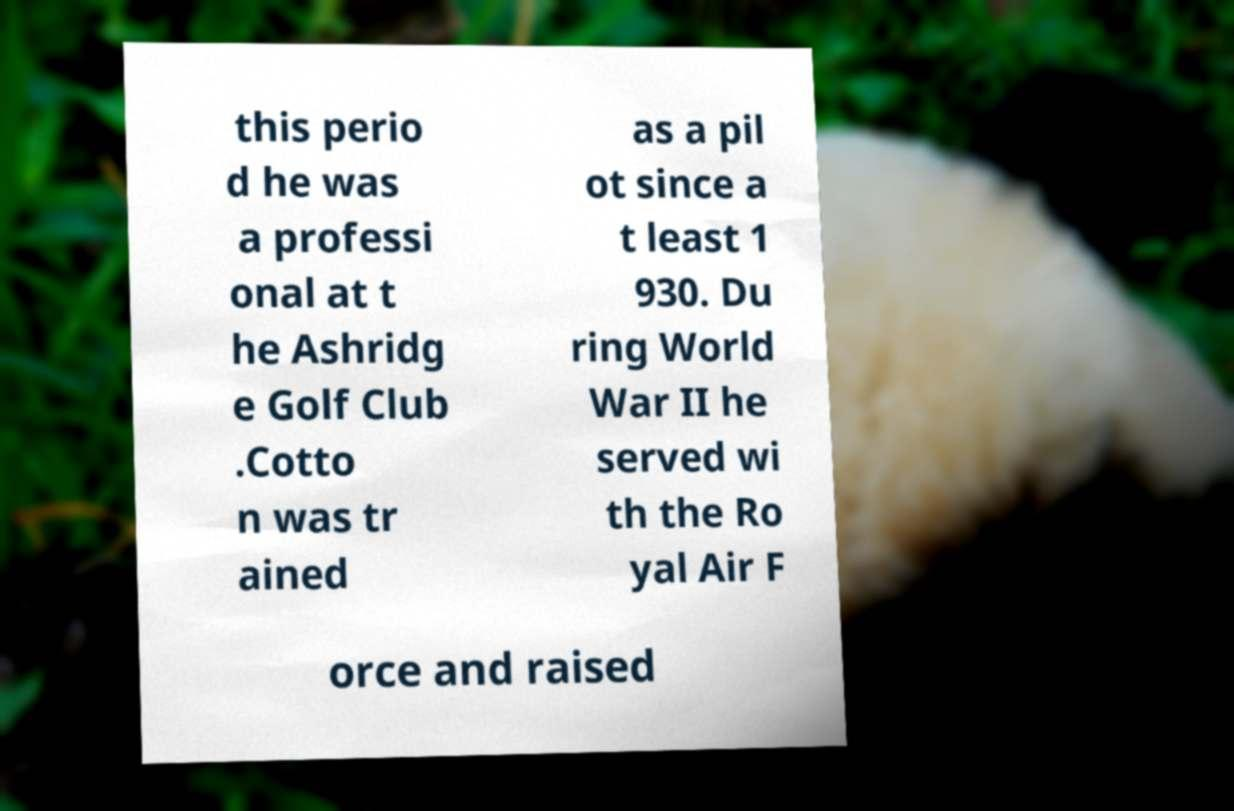There's text embedded in this image that I need extracted. Can you transcribe it verbatim? this perio d he was a professi onal at t he Ashridg e Golf Club .Cotto n was tr ained as a pil ot since a t least 1 930. Du ring World War II he served wi th the Ro yal Air F orce and raised 